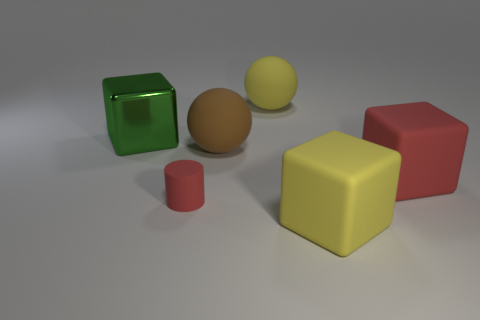Add 1 gray rubber cylinders. How many objects exist? 7 Subtract all cylinders. How many objects are left? 5 Subtract 1 yellow blocks. How many objects are left? 5 Subtract all big yellow rubber balls. Subtract all shiny things. How many objects are left? 4 Add 5 brown rubber things. How many brown rubber things are left? 6 Add 2 cylinders. How many cylinders exist? 3 